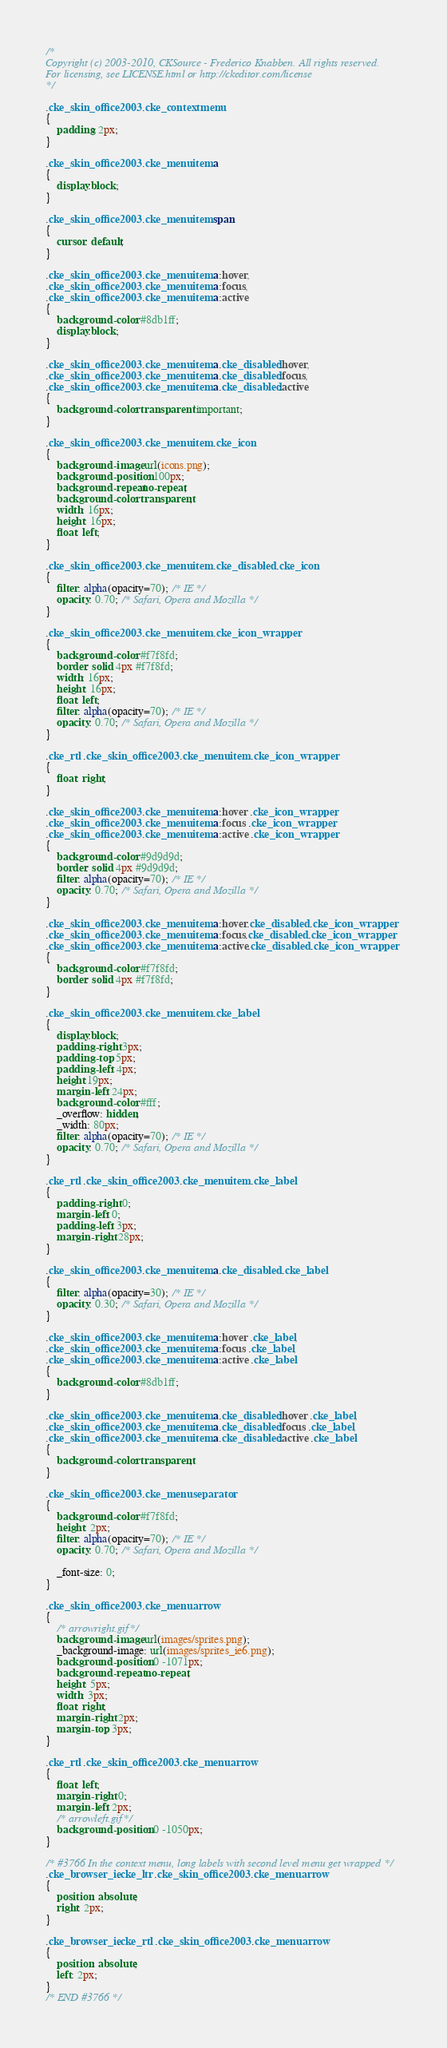<code> <loc_0><loc_0><loc_500><loc_500><_CSS_>/*
Copyright (c) 2003-2010, CKSource - Frederico Knabben. All rights reserved.
For licensing, see LICENSE.html or http://ckeditor.com/license
*/

.cke_skin_office2003 .cke_contextmenu
{
	padding: 2px;
}

.cke_skin_office2003 .cke_menuitem a
{
	display:block;
}

.cke_skin_office2003 .cke_menuitem span
{
	cursor: default;
}

.cke_skin_office2003 .cke_menuitem a:hover,
.cke_skin_office2003 .cke_menuitem a:focus,
.cke_skin_office2003 .cke_menuitem a:active
{
	background-color: #8db1ff;
	display:block;
}

.cke_skin_office2003 .cke_menuitem a.cke_disabled:hover,
.cke_skin_office2003 .cke_menuitem a.cke_disabled:focus,
.cke_skin_office2003 .cke_menuitem a.cke_disabled:active
{
	background-color: transparent !important;
}

.cke_skin_office2003 .cke_menuitem .cke_icon
{
	background-image: url(icons.png);
	background-position: 100px;
	background-repeat:no-repeat;
	background-color: transparent;
	width: 16px;
	height: 16px;
	float: left;
}

.cke_skin_office2003 .cke_menuitem .cke_disabled .cke_icon
{
	filter: alpha(opacity=70); /* IE */
	opacity: 0.70; /* Safari, Opera and Mozilla */
}

.cke_skin_office2003 .cke_menuitem .cke_icon_wrapper
{
	background-color: #f7f8fd;
	border: solid 4px #f7f8fd;
	width: 16px;
	height: 16px;
	float: left;
	filter: alpha(opacity=70); /* IE */
	opacity: 0.70; /* Safari, Opera and Mozilla */
}

.cke_rtl .cke_skin_office2003 .cke_menuitem .cke_icon_wrapper
{
	float: right;
}

.cke_skin_office2003 .cke_menuitem a:hover .cke_icon_wrapper,
.cke_skin_office2003 .cke_menuitem a:focus .cke_icon_wrapper,
.cke_skin_office2003 .cke_menuitem a:active .cke_icon_wrapper
{
	background-color: #9d9d9d;
	border: solid 4px #9d9d9d;
	filter: alpha(opacity=70); /* IE */
	opacity: 0.70; /* Safari, Opera and Mozilla */
}

.cke_skin_office2003 .cke_menuitem a:hover.cke_disabled .cke_icon_wrapper,
.cke_skin_office2003 .cke_menuitem a:focus.cke_disabled .cke_icon_wrapper,
.cke_skin_office2003 .cke_menuitem a:active.cke_disabled .cke_icon_wrapper
{
	background-color: #f7f8fd;
	border: solid 4px #f7f8fd;
}

.cke_skin_office2003 .cke_menuitem .cke_label
{
	display:block;
	padding-right: 3px;
	padding-top: 5px;
	padding-left: 4px;
	height:19px;
	margin-left: 24px;
	background-color: #fff;
	_overflow: hidden;
	_width: 80px;
	filter: alpha(opacity=70); /* IE */
	opacity: 0.70; /* Safari, Opera and Mozilla */
}

.cke_rtl .cke_skin_office2003 .cke_menuitem .cke_label
{
	padding-right: 0;
	margin-left: 0;
	padding-left: 3px;
	margin-right: 28px;
}

.cke_skin_office2003 .cke_menuitem a.cke_disabled .cke_label
{
	filter: alpha(opacity=30); /* IE */
	opacity: 0.30; /* Safari, Opera and Mozilla */
}

.cke_skin_office2003 .cke_menuitem a:hover .cke_label,
.cke_skin_office2003 .cke_menuitem a:focus .cke_label,
.cke_skin_office2003 .cke_menuitem a:active .cke_label
{
	background-color: #8db1ff;
}

.cke_skin_office2003 .cke_menuitem a.cke_disabled:hover .cke_label,
.cke_skin_office2003 .cke_menuitem a.cke_disabled:focus .cke_label,
.cke_skin_office2003 .cke_menuitem a.cke_disabled:active .cke_label
{
	background-color: transparent;
}

.cke_skin_office2003 .cke_menuseparator
{
	background-color: #f7f8fd;
	height: 2px;
	filter: alpha(opacity=70); /* IE */
	opacity: 0.70; /* Safari, Opera and Mozilla */

	_font-size: 0;
}

.cke_skin_office2003 .cke_menuarrow
{
	/* arrowright.gif*/
	background-image: url(images/sprites.png);
	_background-image: url(images/sprites_ie6.png);
	background-position: 0 -1071px;
	background-repeat: no-repeat;
	height: 5px;
	width: 3px;
	float: right;
	margin-right: 2px;
	margin-top: 3px;
}

.cke_rtl .cke_skin_office2003 .cke_menuarrow
{
	float: left;
	margin-right: 0;
	margin-left: 2px;
	/* arrowleft.gif*/
	background-position: 0 -1050px;
}

/* #3766 In the context menu, long labels with second level menu get wrapped */
.cke_browser_ie.cke_ltr .cke_skin_office2003 .cke_menuarrow
{
	position: absolute;
	right: 2px;
}

.cke_browser_ie.cke_rtl .cke_skin_office2003 .cke_menuarrow
{
	position: absolute;
	left: 2px;
}
/* END #3766 */
</code> 